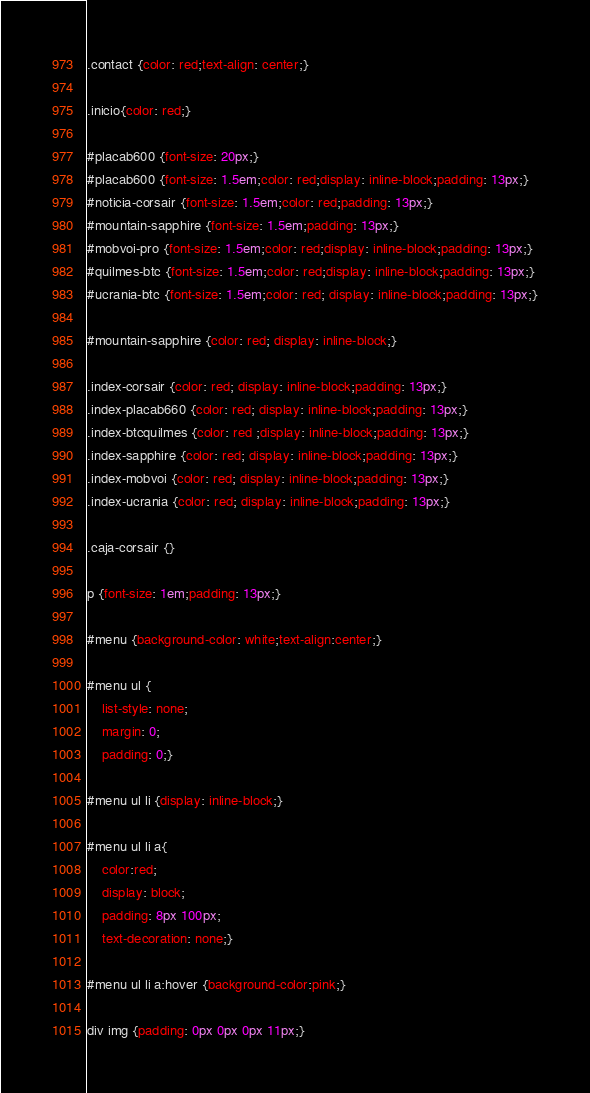Convert code to text. <code><loc_0><loc_0><loc_500><loc_500><_CSS_>.contact {color: red;text-align: center;}

.inicio{color: red;}

#placab600 {font-size: 20px;}
#placab600 {font-size: 1.5em;color: red;display: inline-block;padding: 13px;}
#noticia-corsair {font-size: 1.5em;color: red;padding: 13px;}
#mountain-sapphire {font-size: 1.5em;padding: 13px;}
#mobvoi-pro {font-size: 1.5em;color: red;display: inline-block;padding: 13px;}
#quilmes-btc {font-size: 1.5em;color: red;display: inline-block;padding: 13px;}
#ucrania-btc {font-size: 1.5em;color: red; display: inline-block;padding: 13px;}

#mountain-sapphire {color: red; display: inline-block;}

.index-corsair {color: red; display: inline-block;padding: 13px;}
.index-placab660 {color: red; display: inline-block;padding: 13px;}
.index-btcquilmes {color: red ;display: inline-block;padding: 13px;}
.index-sapphire {color: red; display: inline-block;padding: 13px;}
.index-mobvoi {color: red; display: inline-block;padding: 13px;}
.index-ucrania {color: red; display: inline-block;padding: 13px;}

.caja-corsair {}

p {font-size: 1em;padding: 13px;}

#menu {background-color: white;text-align:center;}

#menu ul { 
	list-style: none;
	margin: 0;
	padding: 0;}

#menu ul li {display: inline-block;}

#menu ul li a{
	color:red;
	display: block;
	padding: 8px 100px;
	text-decoration: none;}

#menu ul li a:hover {background-color:pink;}

div img {padding: 0px 0px 0px 11px;}

</code> 